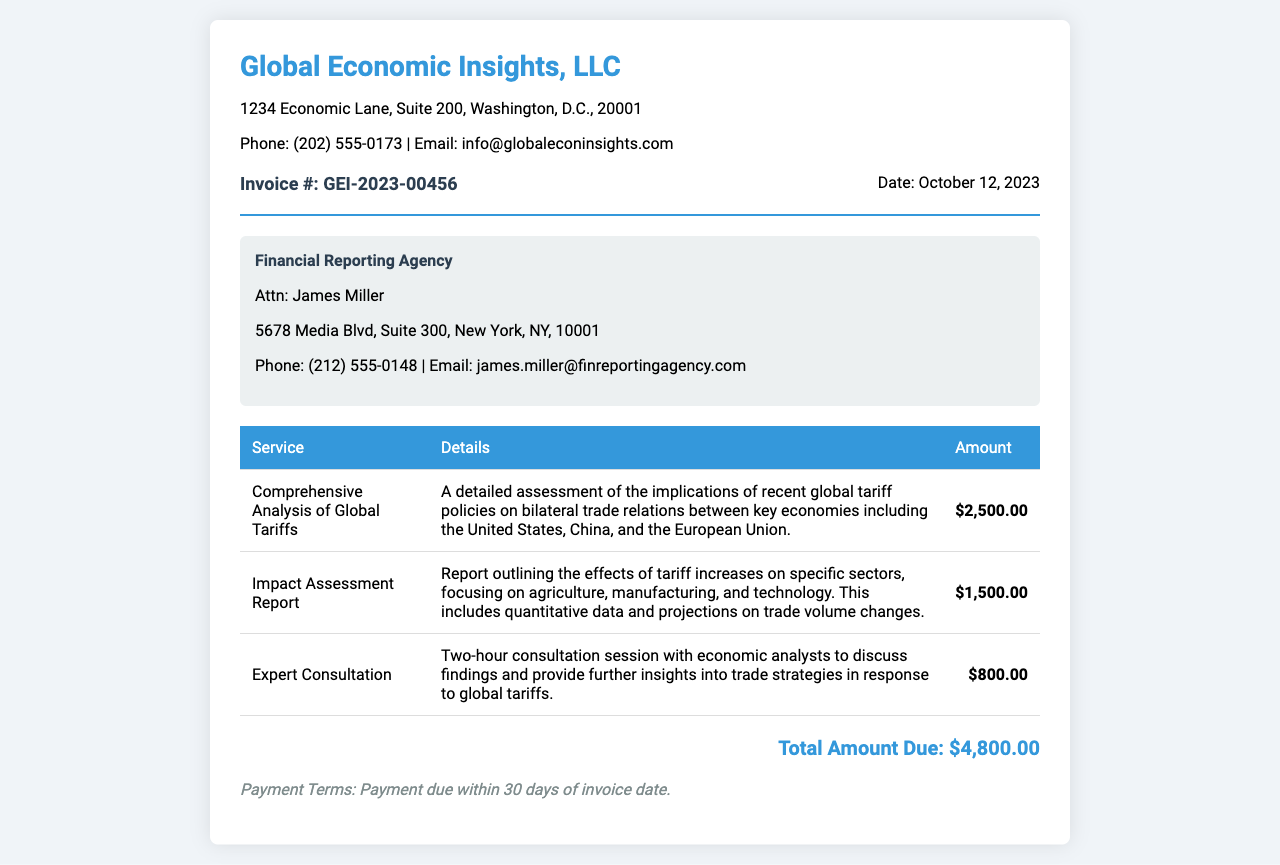What is the invoice number? The invoice number is found under the invoice details section, labeled as Invoice #.
Answer: GEI-2023-00456 What is the date of the invoice? The date of the invoice is presented next to the invoice number in the invoice details section.
Answer: October 12, 2023 Who is the client for this invoice? The client name is listed in the client info section.
Answer: Financial Reporting Agency What is the total amount due? The total amount due is prominently displayed at the bottom of the invoice.
Answer: $4,800.00 What service is associated with the highest amount? The amount for each service is detailed in the table; identifying the highest amount reveals this information.
Answer: Comprehensive Analysis of Global Tariffs How many hours is the expert consultation? The details for the expert consultation outline the duration of the session in the service description.
Answer: Two hours What are the payment terms? Payment terms are specified at the bottom of the invoice, detailing the due timeframe for payment.
Answer: Payment due within 30 days of invoice date What is included in the Impact Assessment Report? An overview of the contents of the report is given in the details column of the services table.
Answer: Effects of tariff increases on specific sectors What is the service amount for the Expert Consultation? The service amount for each item is outlined in the third column of the services table.
Answer: $800.00 